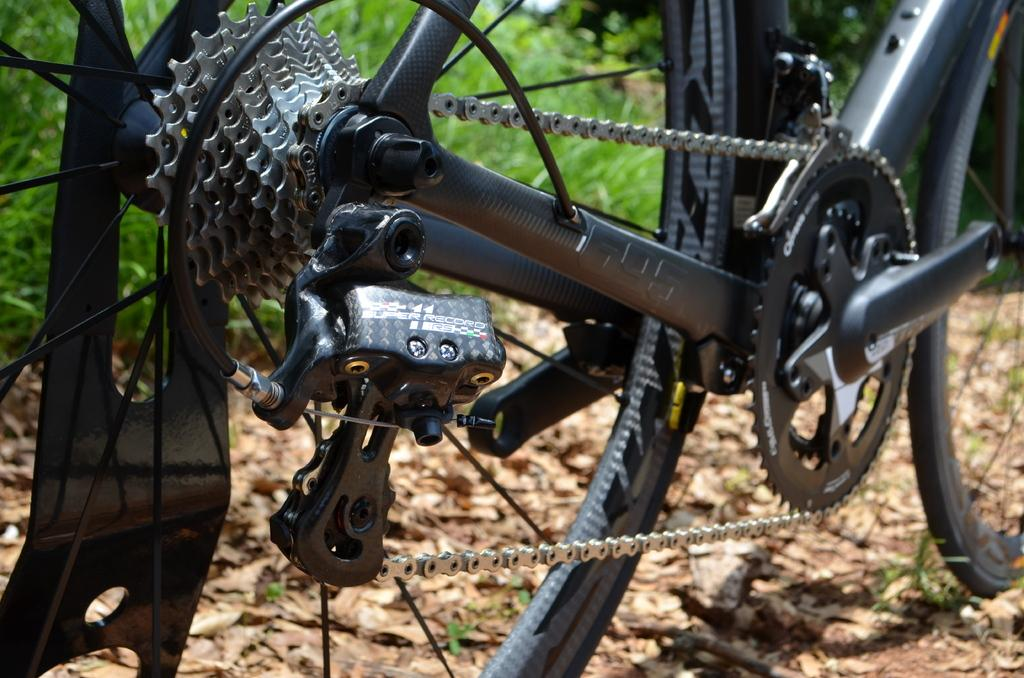What is the main object in the image? There is a cycle in the image. What color is the cycle? The cycle is black in color. What can be seen on the ground in the image? There are leaves on the ground in the image. What type of vegetation is visible in the background? There is grass visible in the background of the image. How does the cycle attempt to cover the leaves on the ground in the image? The cycle does not attempt to cover the leaves on the ground in the image; it is a separate object and not interacting with the leaves. 